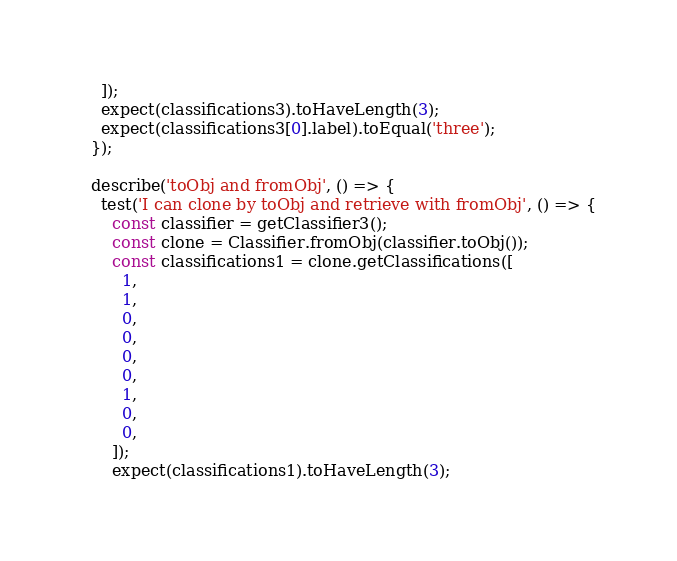<code> <loc_0><loc_0><loc_500><loc_500><_JavaScript_>    ]);
    expect(classifications3).toHaveLength(3);
    expect(classifications3[0].label).toEqual('three');
  });

  describe('toObj and fromObj', () => {
    test('I can clone by toObj and retrieve with fromObj', () => {
      const classifier = getClassifier3();
      const clone = Classifier.fromObj(classifier.toObj());
      const classifications1 = clone.getClassifications([
        1,
        1,
        0,
        0,
        0,
        0,
        1,
        0,
        0,
      ]);
      expect(classifications1).toHaveLength(3);</code> 